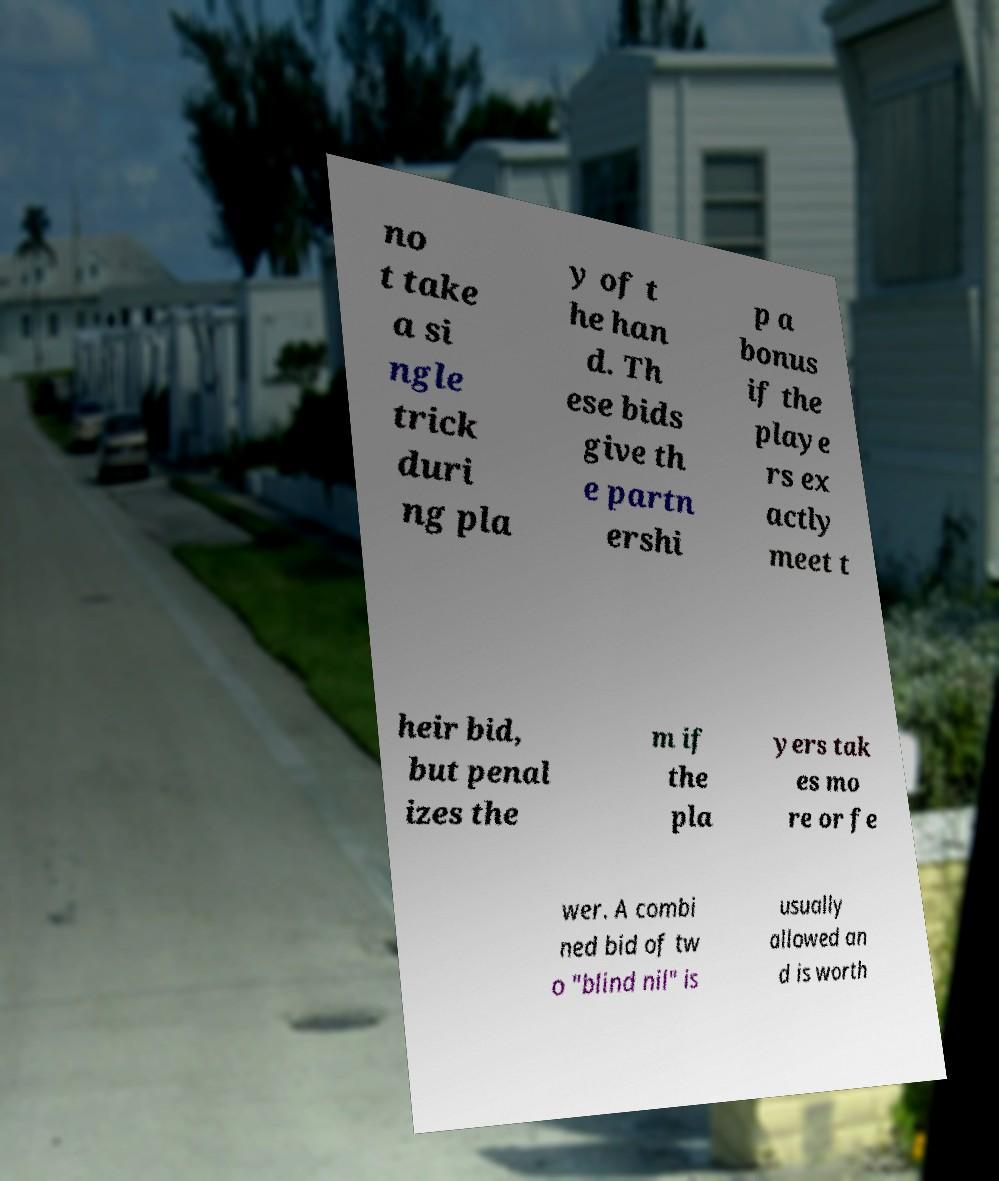Can you read and provide the text displayed in the image?This photo seems to have some interesting text. Can you extract and type it out for me? no t take a si ngle trick duri ng pla y of t he han d. Th ese bids give th e partn ershi p a bonus if the playe rs ex actly meet t heir bid, but penal izes the m if the pla yers tak es mo re or fe wer. A combi ned bid of tw o "blind nil" is usually allowed an d is worth 